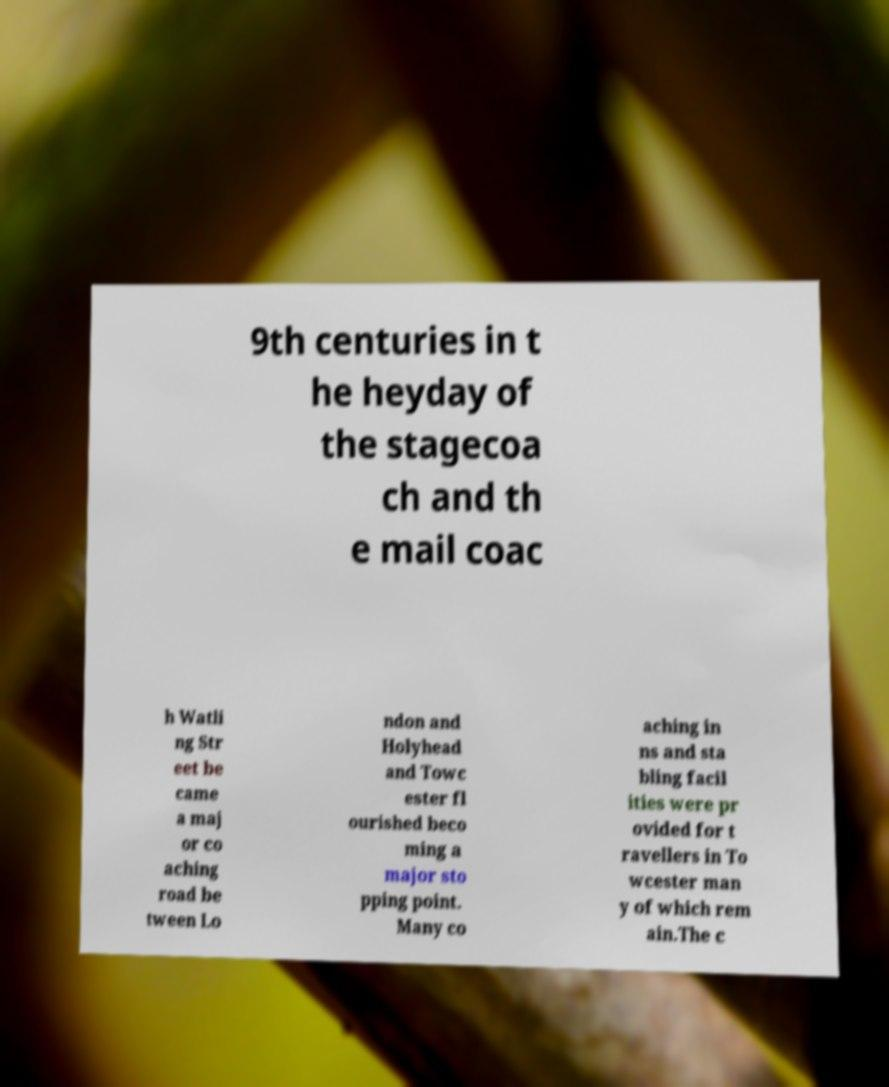For documentation purposes, I need the text within this image transcribed. Could you provide that? 9th centuries in t he heyday of the stagecoa ch and th e mail coac h Watli ng Str eet be came a maj or co aching road be tween Lo ndon and Holyhead and Towc ester fl ourished beco ming a major sto pping point. Many co aching in ns and sta bling facil ities were pr ovided for t ravellers in To wcester man y of which rem ain.The c 